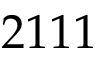<formula> <loc_0><loc_0><loc_500><loc_500>2 1 1 1</formula> 